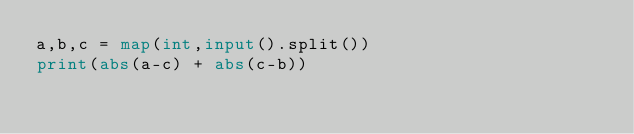<code> <loc_0><loc_0><loc_500><loc_500><_Python_>a,b,c = map(int,input().split())
print(abs(a-c) + abs(c-b))</code> 